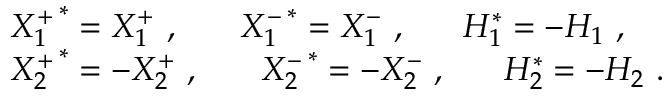<formula> <loc_0><loc_0><loc_500><loc_500>\begin{array} { l } { { X _ { 1 } ^ { + } ^ { * } = X _ { 1 } ^ { + } , X _ { 1 } ^ { - } ^ { * } = X _ { 1 } ^ { - } , H _ { 1 } ^ { * } = - H _ { 1 } , } } \\ { { X _ { 2 } ^ { + } ^ { * } = - X _ { 2 } ^ { + } , X _ { 2 } ^ { - } ^ { * } = - X _ { 2 } ^ { - } , H _ { 2 } ^ { * } = - H _ { 2 } . } } \end{array}</formula> 